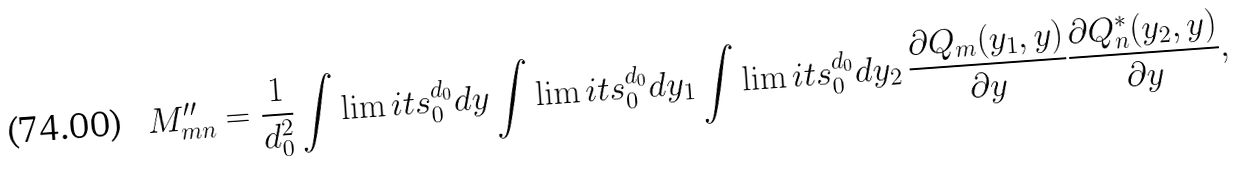Convert formula to latex. <formula><loc_0><loc_0><loc_500><loc_500>M _ { m n } ^ { \prime \prime } = \frac { 1 } { d _ { 0 } ^ { 2 } } \int \lim i t s _ { 0 } ^ { d _ { 0 } } d y \int \lim i t s _ { 0 } ^ { d _ { 0 } } d y _ { 1 } \int \lim i t s _ { 0 } ^ { d _ { 0 } } d y _ { 2 } \, \frac { \partial Q _ { m } ( y _ { 1 } , y ) } { \partial y } \frac { \partial Q _ { n } ^ { * } ( y _ { 2 } , y ) } { \partial y } ,</formula> 